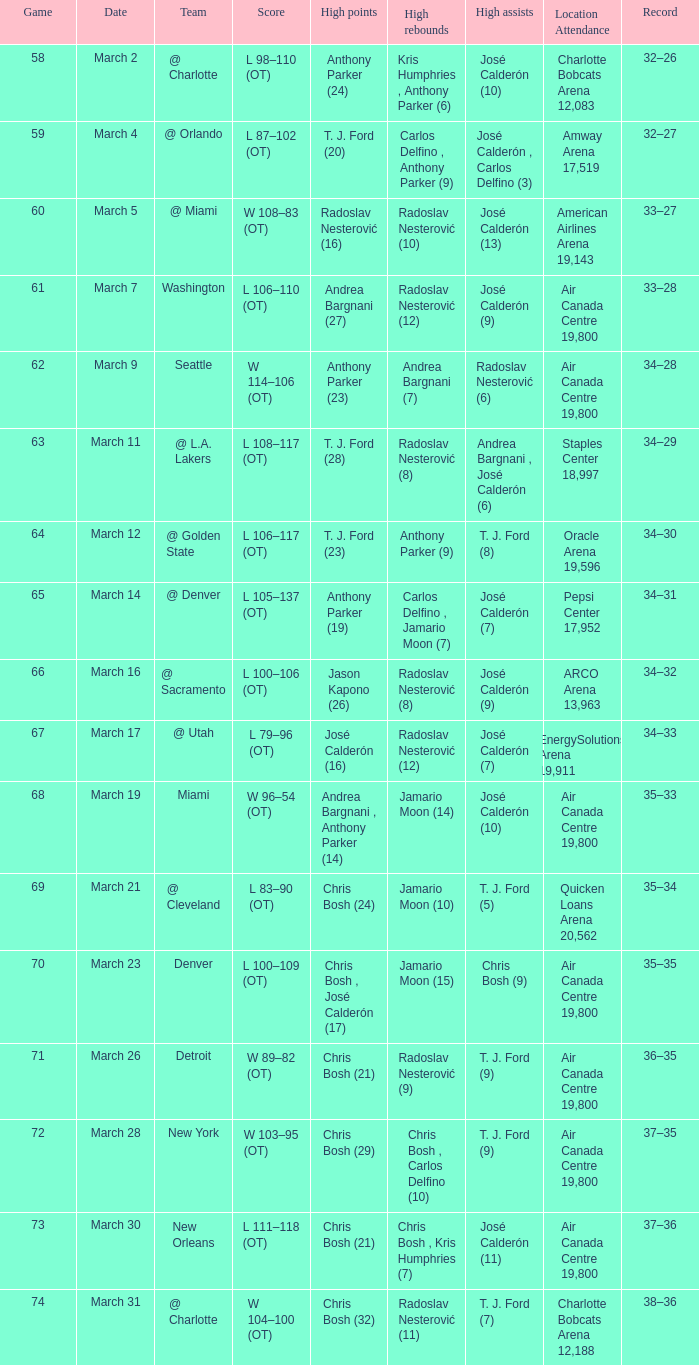What numbered game featured a High rebounds of radoslav nesterović (8), and a High assists of josé calderón (9)? 1.0. 